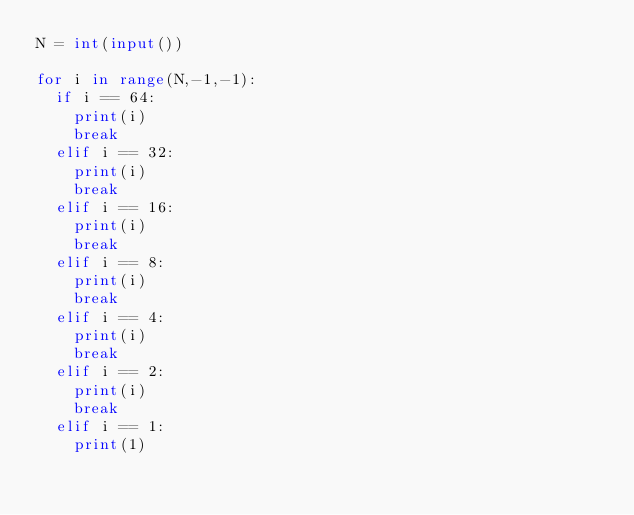Convert code to text. <code><loc_0><loc_0><loc_500><loc_500><_Python_>N = int(input())

for i in range(N,-1,-1):
  if i == 64:
    print(i)
    break
  elif i == 32:
    print(i)
    break
  elif i == 16:
    print(i)
    break
  elif i == 8:
    print(i)
    break
  elif i == 4:
    print(i)
    break
  elif i == 2:
    print(i)
    break
  elif i == 1:
    print(1)
  
    
    
   
    

</code> 